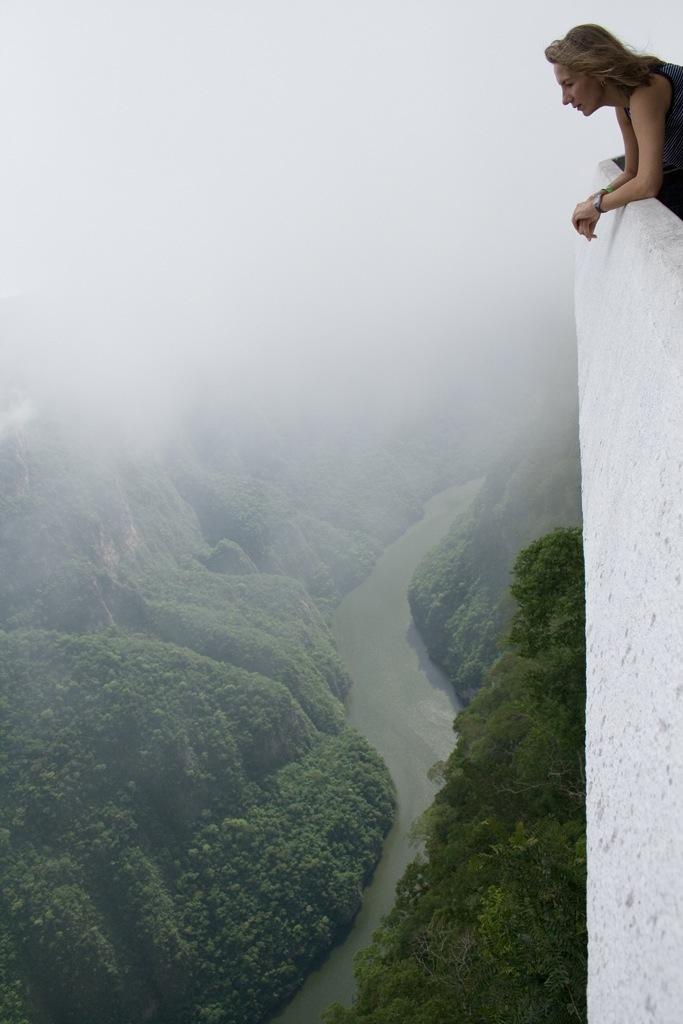Please provide a concise description of this image. In this picture there is a woman standing behind the wall. At the bottom there are mountains and there are trees and there is water. At the top it looks like fog. 